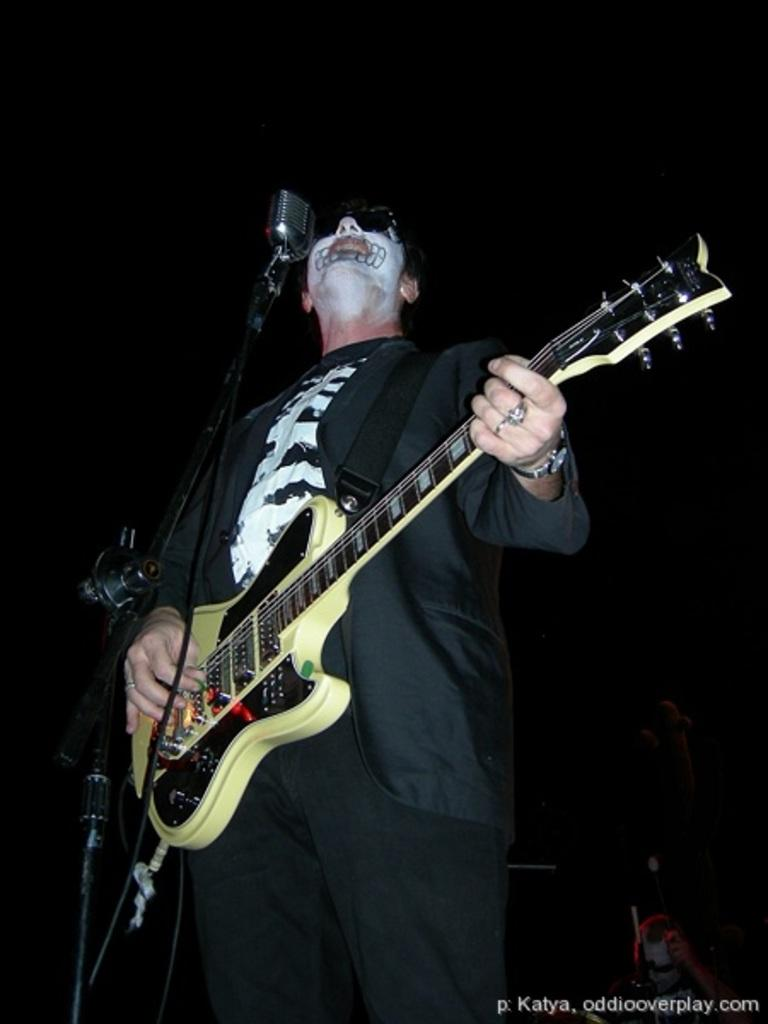Who is the main subject in the image? There is a man in the center of the image. What is the man doing in the image? The man is standing and playing a guitar. What object is in front of the man? There is a microphone (mic) before the man. Can you describe the man's appearance in the image? The man has face painting on his face. What type of wind can be seen blowing through the image? There is no wind present in the image. 